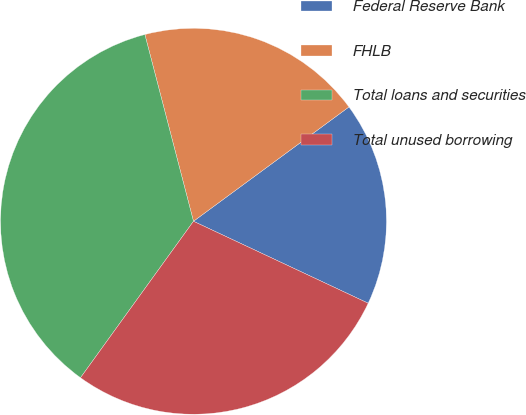<chart> <loc_0><loc_0><loc_500><loc_500><pie_chart><fcel>Federal Reserve Bank<fcel>FHLB<fcel>Total loans and securities<fcel>Total unused borrowing<nl><fcel>17.07%<fcel>18.96%<fcel>35.99%<fcel>27.97%<nl></chart> 